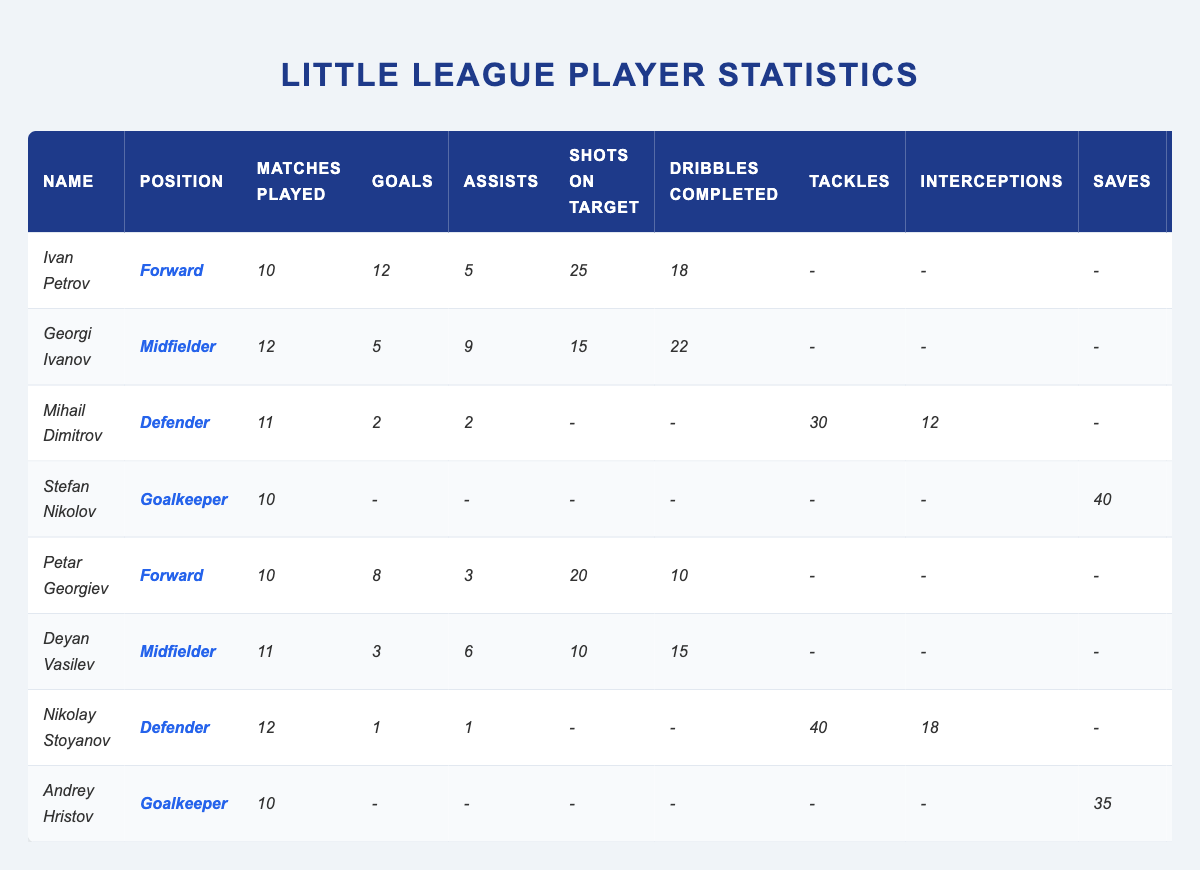What is the total number of goals scored by forwards? The forwards are Ivan Petrov and Petar Georgiev. Ivan scored 12 goals, and Petar scored 8 goals. Adding these together gives: 12 + 8 = 20.
Answer: 20 Which player has the most assists? Looking at the assists column, Georgi Ivanov has 9 assists, which is the highest among all players.
Answer: Georgi Ivanov How many matches did Mihail Dimitrov play? The table shows that Mihail Dimitrov played 11 matches.
Answer: 11 What is the average number of goals scored by the defenders? The defenders are Mihail Dimitrov (2 goals) and Nikolay Stoyanov (1 goal). The total goals scored by defenders = 2 + 1 = 3. There are 2 defenders, so the average = 3 / 2 = 1.5.
Answer: 1.5 Did any player receive a penalty saved? Looking at the penalties saved column, only Stefan Nikolov has saved 1 penalty, and Andrey Hristov has saved none. Therefore, yes, there is at least one player who has saved a penalty.
Answer: Yes What is the difference in goals scored between the highest and lowest goal scorer? The highest goal scorer is Ivan Petrov with 12 goals, and the lowest goal scorer is Nikolay Stoyanov with 1 goal. The difference is 12 - 1 = 11.
Answer: 11 How many total shots on target did the midfielders have? The midfielders are Georgi Ivanov (15 shots) and Deyan Vasilev (10 shots). Adding these gives: 15 + 10 = 25 total shots on target.
Answer: 25 Which goalkeeper has the best clean sheet record? Stefan Nikolov has 4 clean sheets while Andrey Hristov has 5 clean sheets. Therefore, Andrey Hristov has the best clean sheet record.
Answer: Andrey Hristov If we combine the goals scored by all players, what would be the total? Adding together the goals: 12 (Ivan) + 5 (Georgi) + 2 (Mihail) + 0 (Stefan) + 8 (Petar) + 3 (Deyan) + 1 (Nikolay) + 0 (Andrey) gives a total of 31 goals.
Answer: 31 How many players scored more than 5 goals? Ivan Petrov (12 goals) and Petar Georgiev (8 goals) are the only two players who scored more than 5 goals. Therefore, there are 2 players.
Answer: 2 